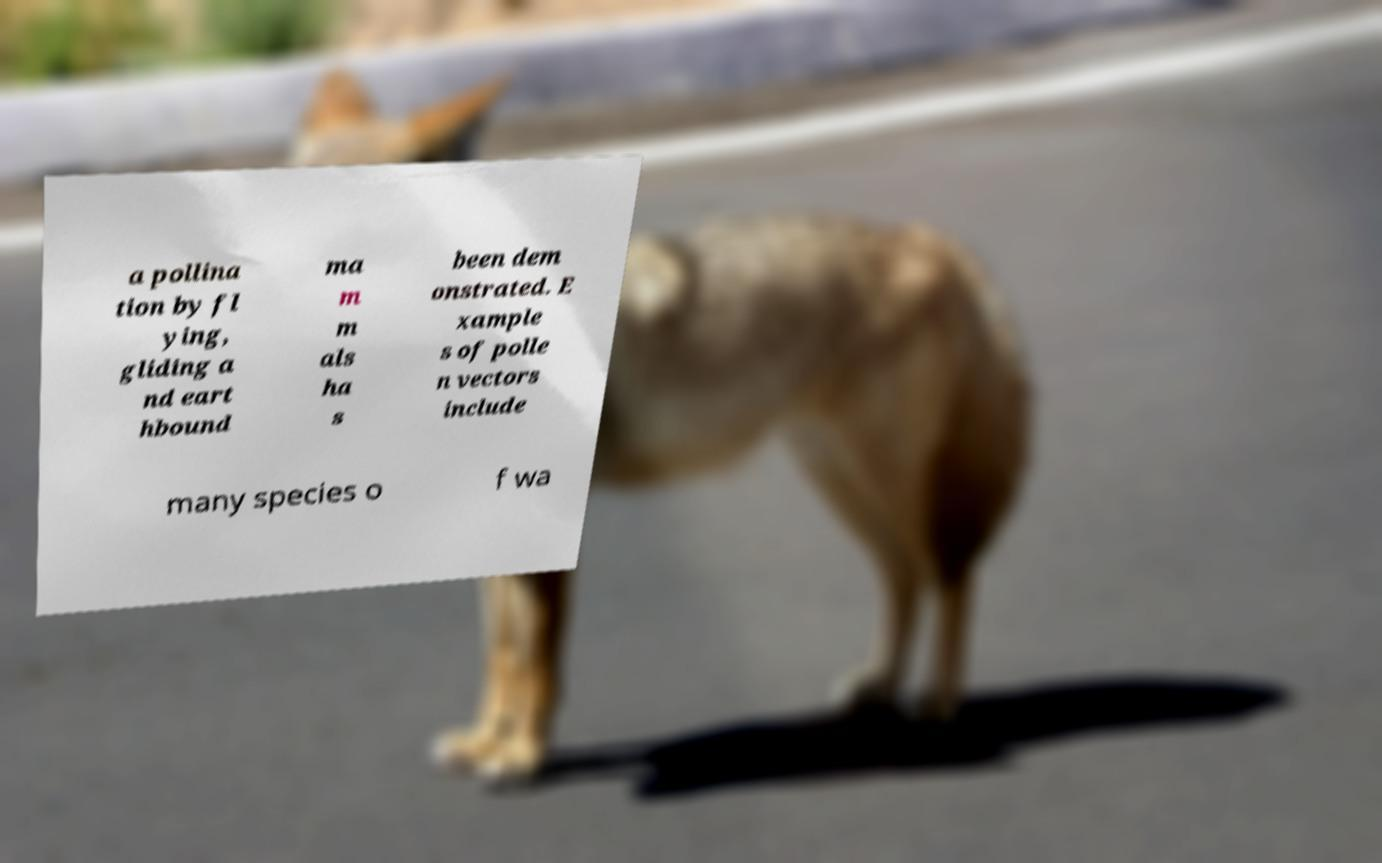I need the written content from this picture converted into text. Can you do that? a pollina tion by fl ying, gliding a nd eart hbound ma m m als ha s been dem onstrated. E xample s of polle n vectors include many species o f wa 